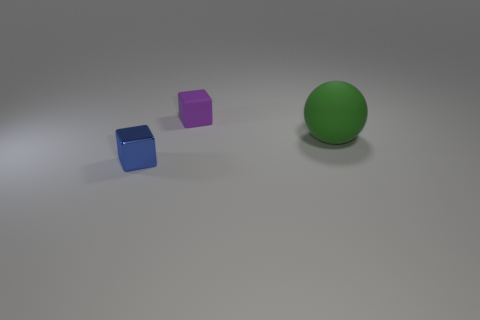Add 2 large spheres. How many objects exist? 5 Subtract all spheres. How many objects are left? 2 Subtract all big green rubber cubes. Subtract all blocks. How many objects are left? 1 Add 1 small metallic cubes. How many small metallic cubes are left? 2 Add 1 blocks. How many blocks exist? 3 Subtract 0 green cylinders. How many objects are left? 3 